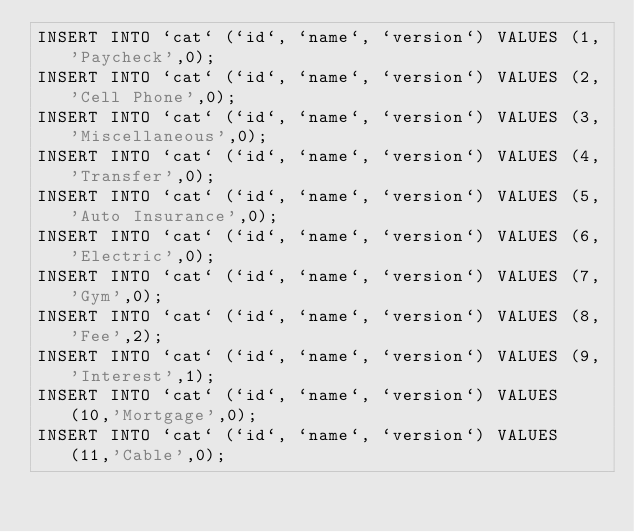Convert code to text. <code><loc_0><loc_0><loc_500><loc_500><_SQL_>INSERT INTO `cat` (`id`, `name`, `version`) VALUES (1,'Paycheck',0);
INSERT INTO `cat` (`id`, `name`, `version`) VALUES (2,'Cell Phone',0);
INSERT INTO `cat` (`id`, `name`, `version`) VALUES (3,'Miscellaneous',0);
INSERT INTO `cat` (`id`, `name`, `version`) VALUES (4,'Transfer',0);
INSERT INTO `cat` (`id`, `name`, `version`) VALUES (5,'Auto Insurance',0);
INSERT INTO `cat` (`id`, `name`, `version`) VALUES (6,'Electric',0);
INSERT INTO `cat` (`id`, `name`, `version`) VALUES (7,'Gym',0);
INSERT INTO `cat` (`id`, `name`, `version`) VALUES (8,'Fee',2);
INSERT INTO `cat` (`id`, `name`, `version`) VALUES (9,'Interest',1);
INSERT INTO `cat` (`id`, `name`, `version`) VALUES (10,'Mortgage',0);
INSERT INTO `cat` (`id`, `name`, `version`) VALUES (11,'Cable',0);</code> 